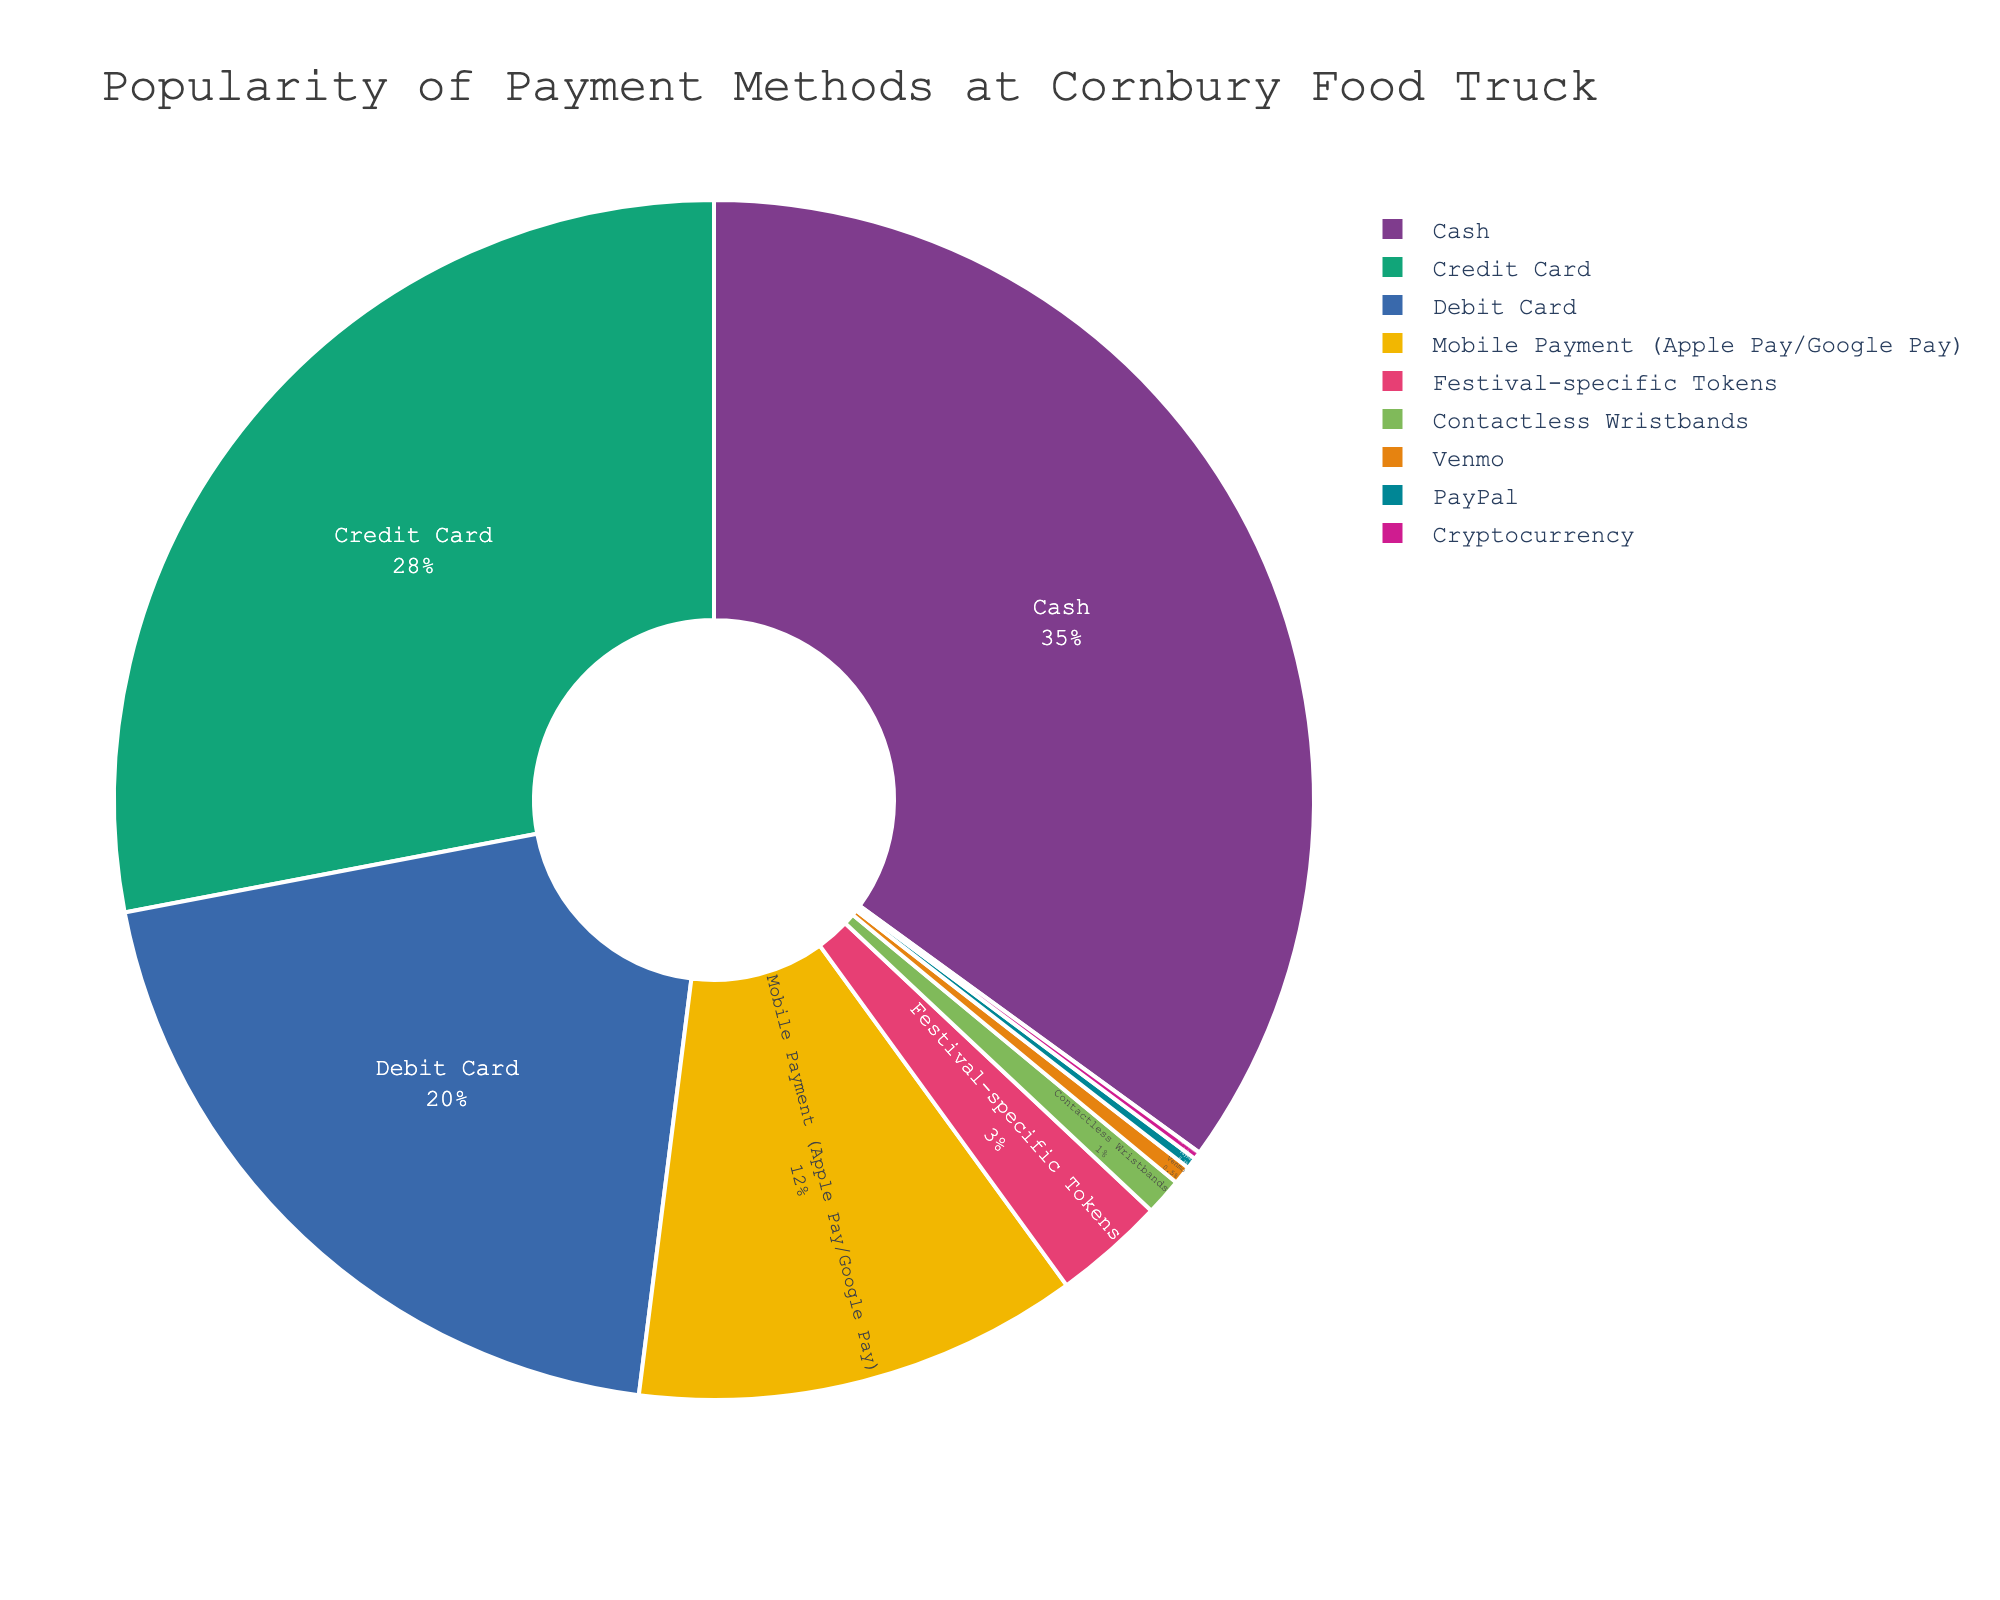What percentage of customers use cash? Look at the segment of the pie chart labeled "Cash" and read the corresponding percentage.
Answer: 35% Which payment method is used the least by customers? Identify the smallest segment in the pie chart and read its label.
Answer: Cryptocurrency What is the combined percentage of customers using either debit or credit cards? Locate the segments labeled "Debit Card" and "Credit Card" in the pie chart, then add their percentages (28% + 20%).
Answer: 48% How much more popular is Mobile Payment compared to Festival-specific Tokens? Find the percentages for "Mobile Payment" and "Festival-specific Tokens" and calculate the difference (12% - 3%).
Answer: 9% Which methods make up at least 10% of the total usage? Identify segments in the pie chart with percentages equal to or greater than 10%. These are "Cash" (35%), "Credit Card" (28%), "Debit Card" (20%), and "Mobile Payment" (12%).
Answer: Cash, Credit Card, Debit Card, and Mobile Payment What percentage of customers use non-traditional payment methods (Mobile Payment, Festival-specific Tokens, Contactless Wristbands, Venmo, PayPal, Cryptocurrency)? Add the percentages for "Mobile Payment" (12%), "Festival-specific Tokens" (3%), "Contactless Wristbands" (1%), "Venmo" (0.5%), "PayPal" (0.3%), and "Cryptocurrency" (0.2%).
Answer: 17% Is the usage of Credit Cards more than double the usage of Mobile Payment? Compare the percentages: Credit Card (28%) versus Mobile Payment (12%). Check if 28% > 12% * 2.
Answer: No Which payment method segment is represented by the second largest portion of the pie chart? Identify the second largest segment visually and verify its label.
Answer: Credit Card By how many percentage points does the use of Contactless Wristbands differ from Venmo? Calculate the difference between the percentages for "Contactless Wristbands" (1%) and "Venmo" (0.5%).
Answer: 0.5% What percentage of customers use PayPal or Cryptocurrency combined? Add the percentages for "PayPal" (0.3%) and "Cryptocurrency" (0.2%).
Answer: 0.5% 